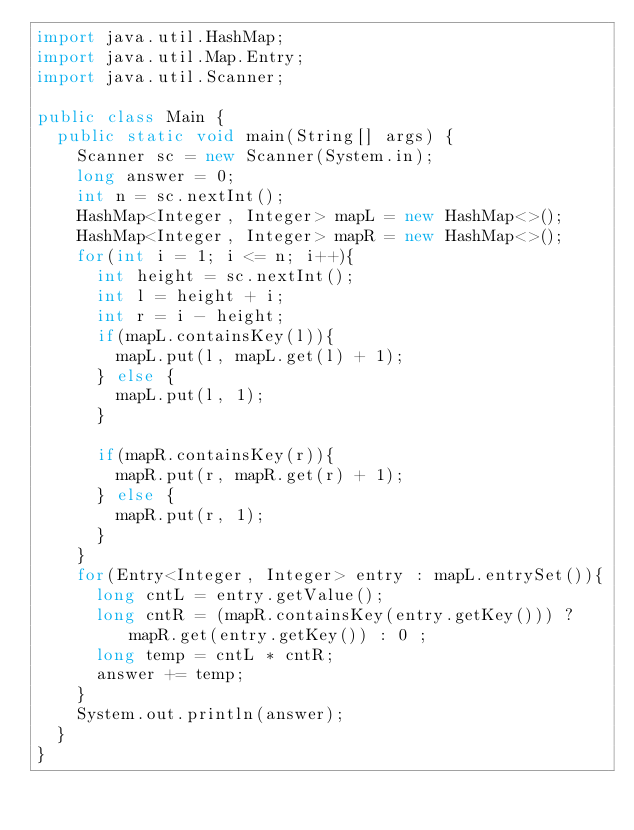<code> <loc_0><loc_0><loc_500><loc_500><_Java_>import java.util.HashMap;
import java.util.Map.Entry;
import java.util.Scanner;

public class Main {
  public static void main(String[] args) {
    Scanner sc = new Scanner(System.in);
    long answer = 0;
    int n = sc.nextInt();
    HashMap<Integer, Integer> mapL = new HashMap<>();
    HashMap<Integer, Integer> mapR = new HashMap<>();
    for(int i = 1; i <= n; i++){
      int height = sc.nextInt();
      int l = height + i;
      int r = i - height;
      if(mapL.containsKey(l)){
        mapL.put(l, mapL.get(l) + 1);
      } else {
        mapL.put(l, 1);
      }

      if(mapR.containsKey(r)){
        mapR.put(r, mapR.get(r) + 1);
      } else {
        mapR.put(r, 1);
      }
    }
    for(Entry<Integer, Integer> entry : mapL.entrySet()){
      long cntL = entry.getValue();
      long cntR = (mapR.containsKey(entry.getKey())) ? mapR.get(entry.getKey()) : 0 ;
      long temp = cntL * cntR;
      answer += temp;
    }
    System.out.println(answer);
  }
}</code> 